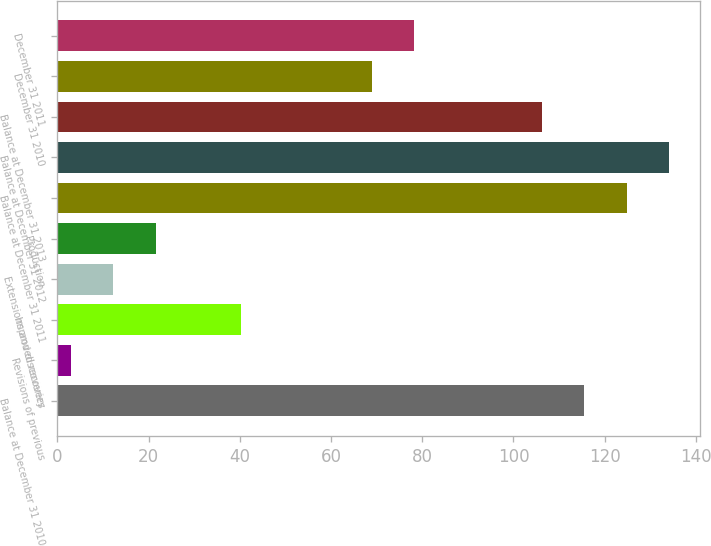Convert chart to OTSL. <chart><loc_0><loc_0><loc_500><loc_500><bar_chart><fcel>Balance at December 31 2010<fcel>Revisions of previous<fcel>Improved recovery<fcel>Extensions and discoveries<fcel>Production<fcel>Balance at December 31 2011<fcel>Balance at December 31 2012<fcel>Balance at December 31 2013<fcel>December 31 2010<fcel>December 31 2011<nl><fcel>115.5<fcel>3<fcel>40.2<fcel>12.3<fcel>21.6<fcel>124.8<fcel>134.1<fcel>106.2<fcel>69<fcel>78.3<nl></chart> 